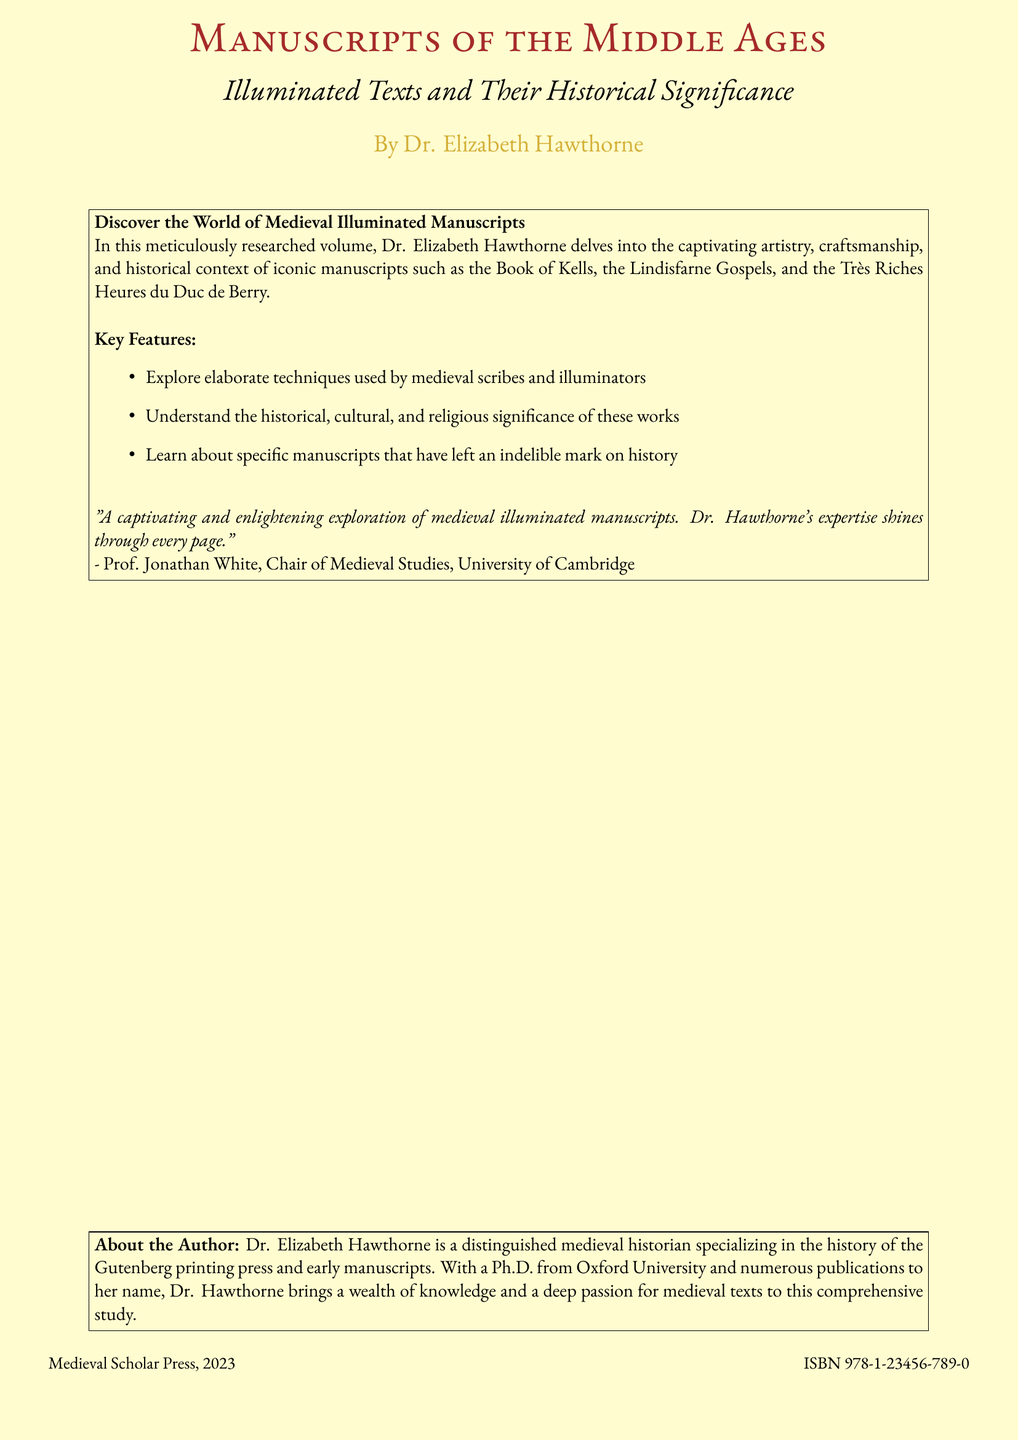What is the title of the book? The title is prominently displayed on the cover and is "Manuscripts of the Middle Ages."
Answer: Manuscripts of the Middle Ages Who is the author of the book? The author's name is listed on the cover as Dr. Elizabeth Hawthorne.
Answer: Dr. Elizabeth Hawthorne What year was the book published? The publication year is noted at the bottom of the cover as 2023.
Answer: 2023 What does the book explore? The book explores the artistry, craftsmanship, and historical context of medieval illuminated manuscripts.
Answer: Illuminated manuscripts What institution is Prof. Jonathan White associated with? Prof. Jonathan White's affiliation is mentioned as the University of Cambridge.
Answer: University of Cambridge Which manuscript is specifically mentioned first in the text box? The first manuscript mentioned is the Book of Kells.
Answer: Book of Kells What color is used for the author's name? The color used for Dr. Hawthorne's name is medieval gold.
Answer: medieval gold What is the ISBN of the book? The ISBN is listed at the bottom of the cover as 978-1-23456-789-0.
Answer: 978-1-23456-789-0 What type of manuscript techniques does the book explore? The book explores elaborate techniques used by medieval scribes and illuminators.
Answer: Elaborate techniques What is the structure of the document? The document exhibits a book cover structure with a title, author, features, and reviews.
Answer: Book cover 